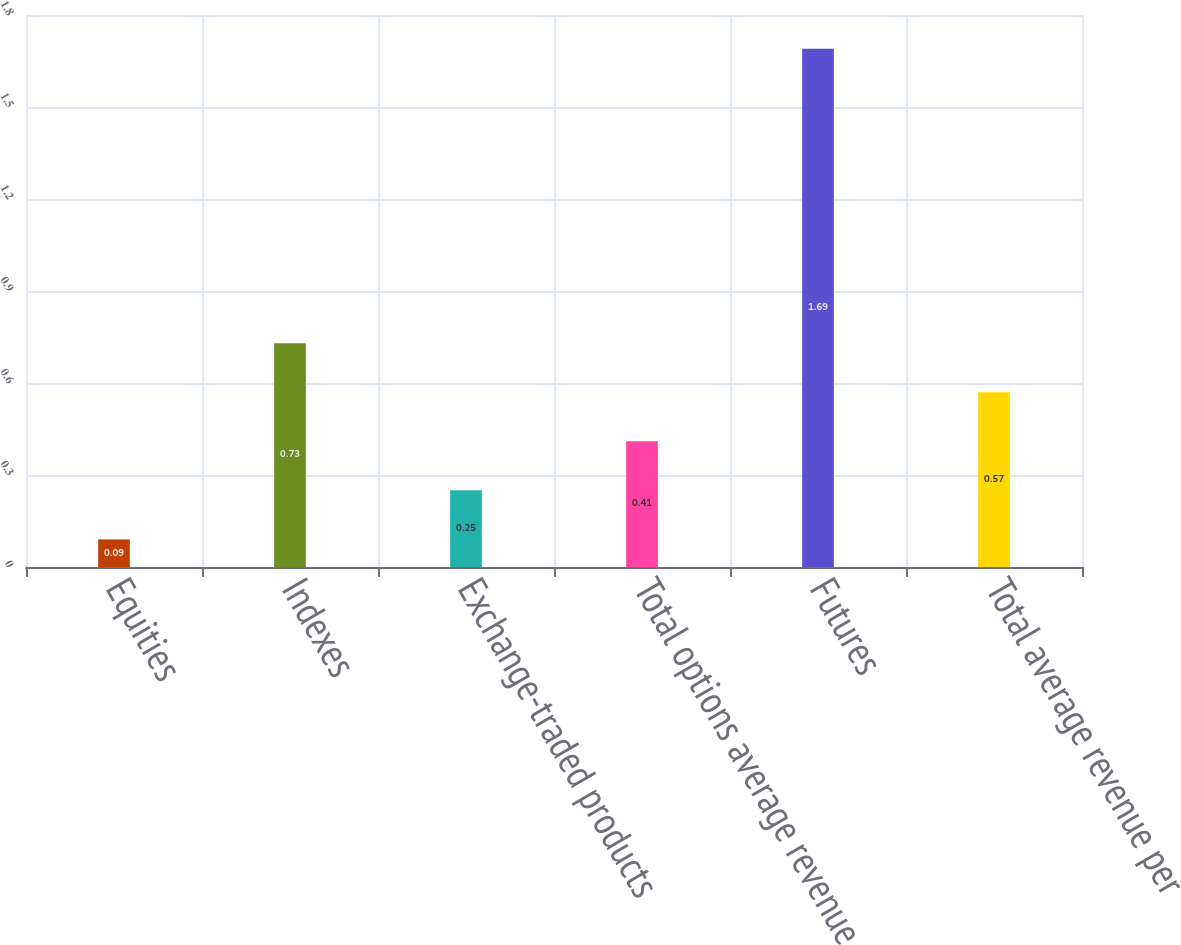<chart> <loc_0><loc_0><loc_500><loc_500><bar_chart><fcel>Equities<fcel>Indexes<fcel>Exchange-traded products<fcel>Total options average revenue<fcel>Futures<fcel>Total average revenue per<nl><fcel>0.09<fcel>0.73<fcel>0.25<fcel>0.41<fcel>1.69<fcel>0.57<nl></chart> 